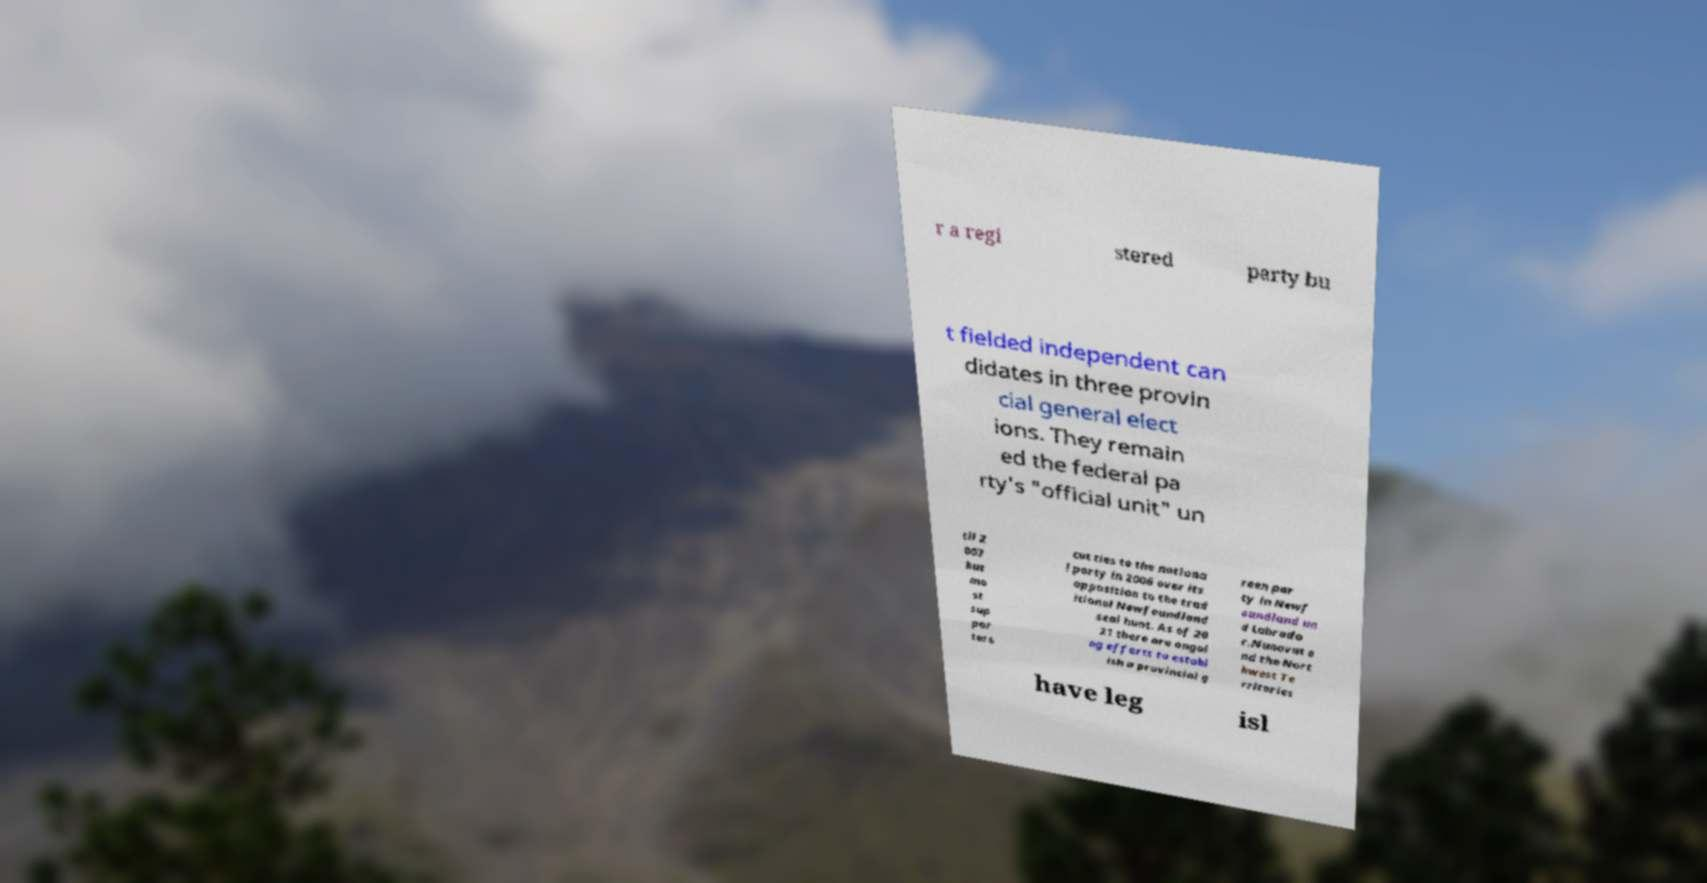Please read and relay the text visible in this image. What does it say? r a regi stered party bu t fielded independent can didates in three provin cial general elect ions. They remain ed the federal pa rty's "official unit" un til 2 007 but mo st sup por ters cut ties to the nationa l party in 2006 over its opposition to the trad itional Newfoundland seal hunt. As of 20 21 there are ongoi ng efforts to establ ish a provincial g reen par ty in Newf oundland an d Labrado r.Nunavut a nd the Nort hwest Te rritories have leg isl 